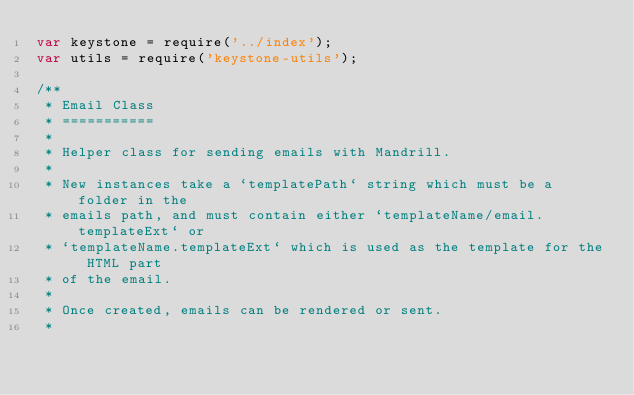Convert code to text. <code><loc_0><loc_0><loc_500><loc_500><_JavaScript_>var keystone = require('../index');
var utils = require('keystone-utils');

/**
 * Email Class
 * ===========
 *
 * Helper class for sending emails with Mandrill.
 *
 * New instances take a `templatePath` string which must be a folder in the
 * emails path, and must contain either `templateName/email.templateExt` or
 * `templateName.templateExt` which is used as the template for the HTML part
 * of the email.
 *
 * Once created, emails can be rendered or sent.
 *</code> 